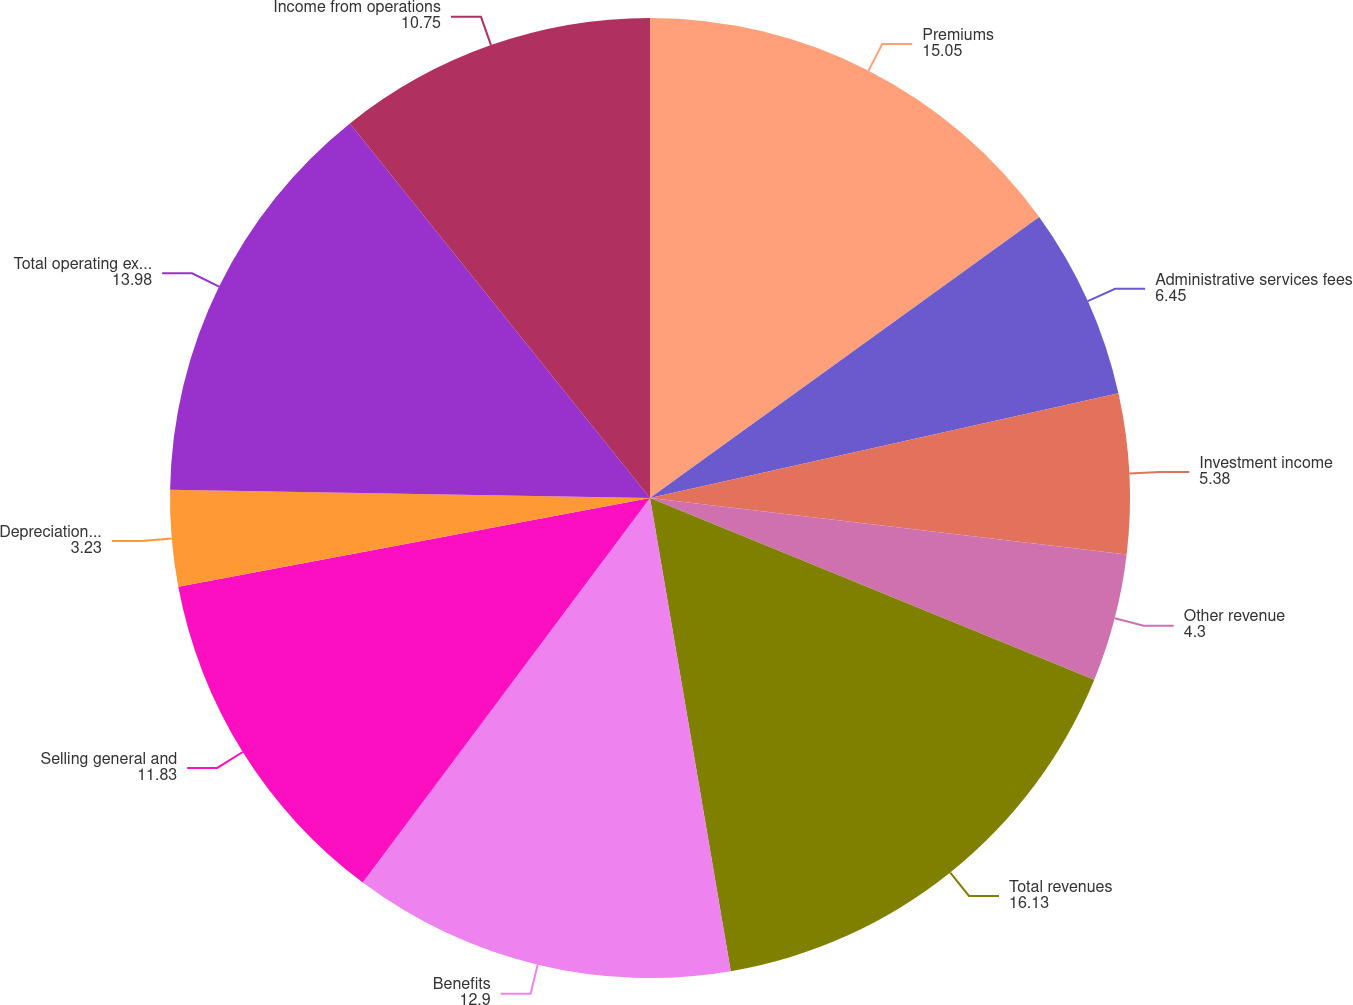<chart> <loc_0><loc_0><loc_500><loc_500><pie_chart><fcel>Premiums<fcel>Administrative services fees<fcel>Investment income<fcel>Other revenue<fcel>Total revenues<fcel>Benefits<fcel>Selling general and<fcel>Depreciation and amortization<fcel>Total operating expenses<fcel>Income from operations<nl><fcel>15.05%<fcel>6.45%<fcel>5.38%<fcel>4.3%<fcel>16.13%<fcel>12.9%<fcel>11.83%<fcel>3.23%<fcel>13.98%<fcel>10.75%<nl></chart> 